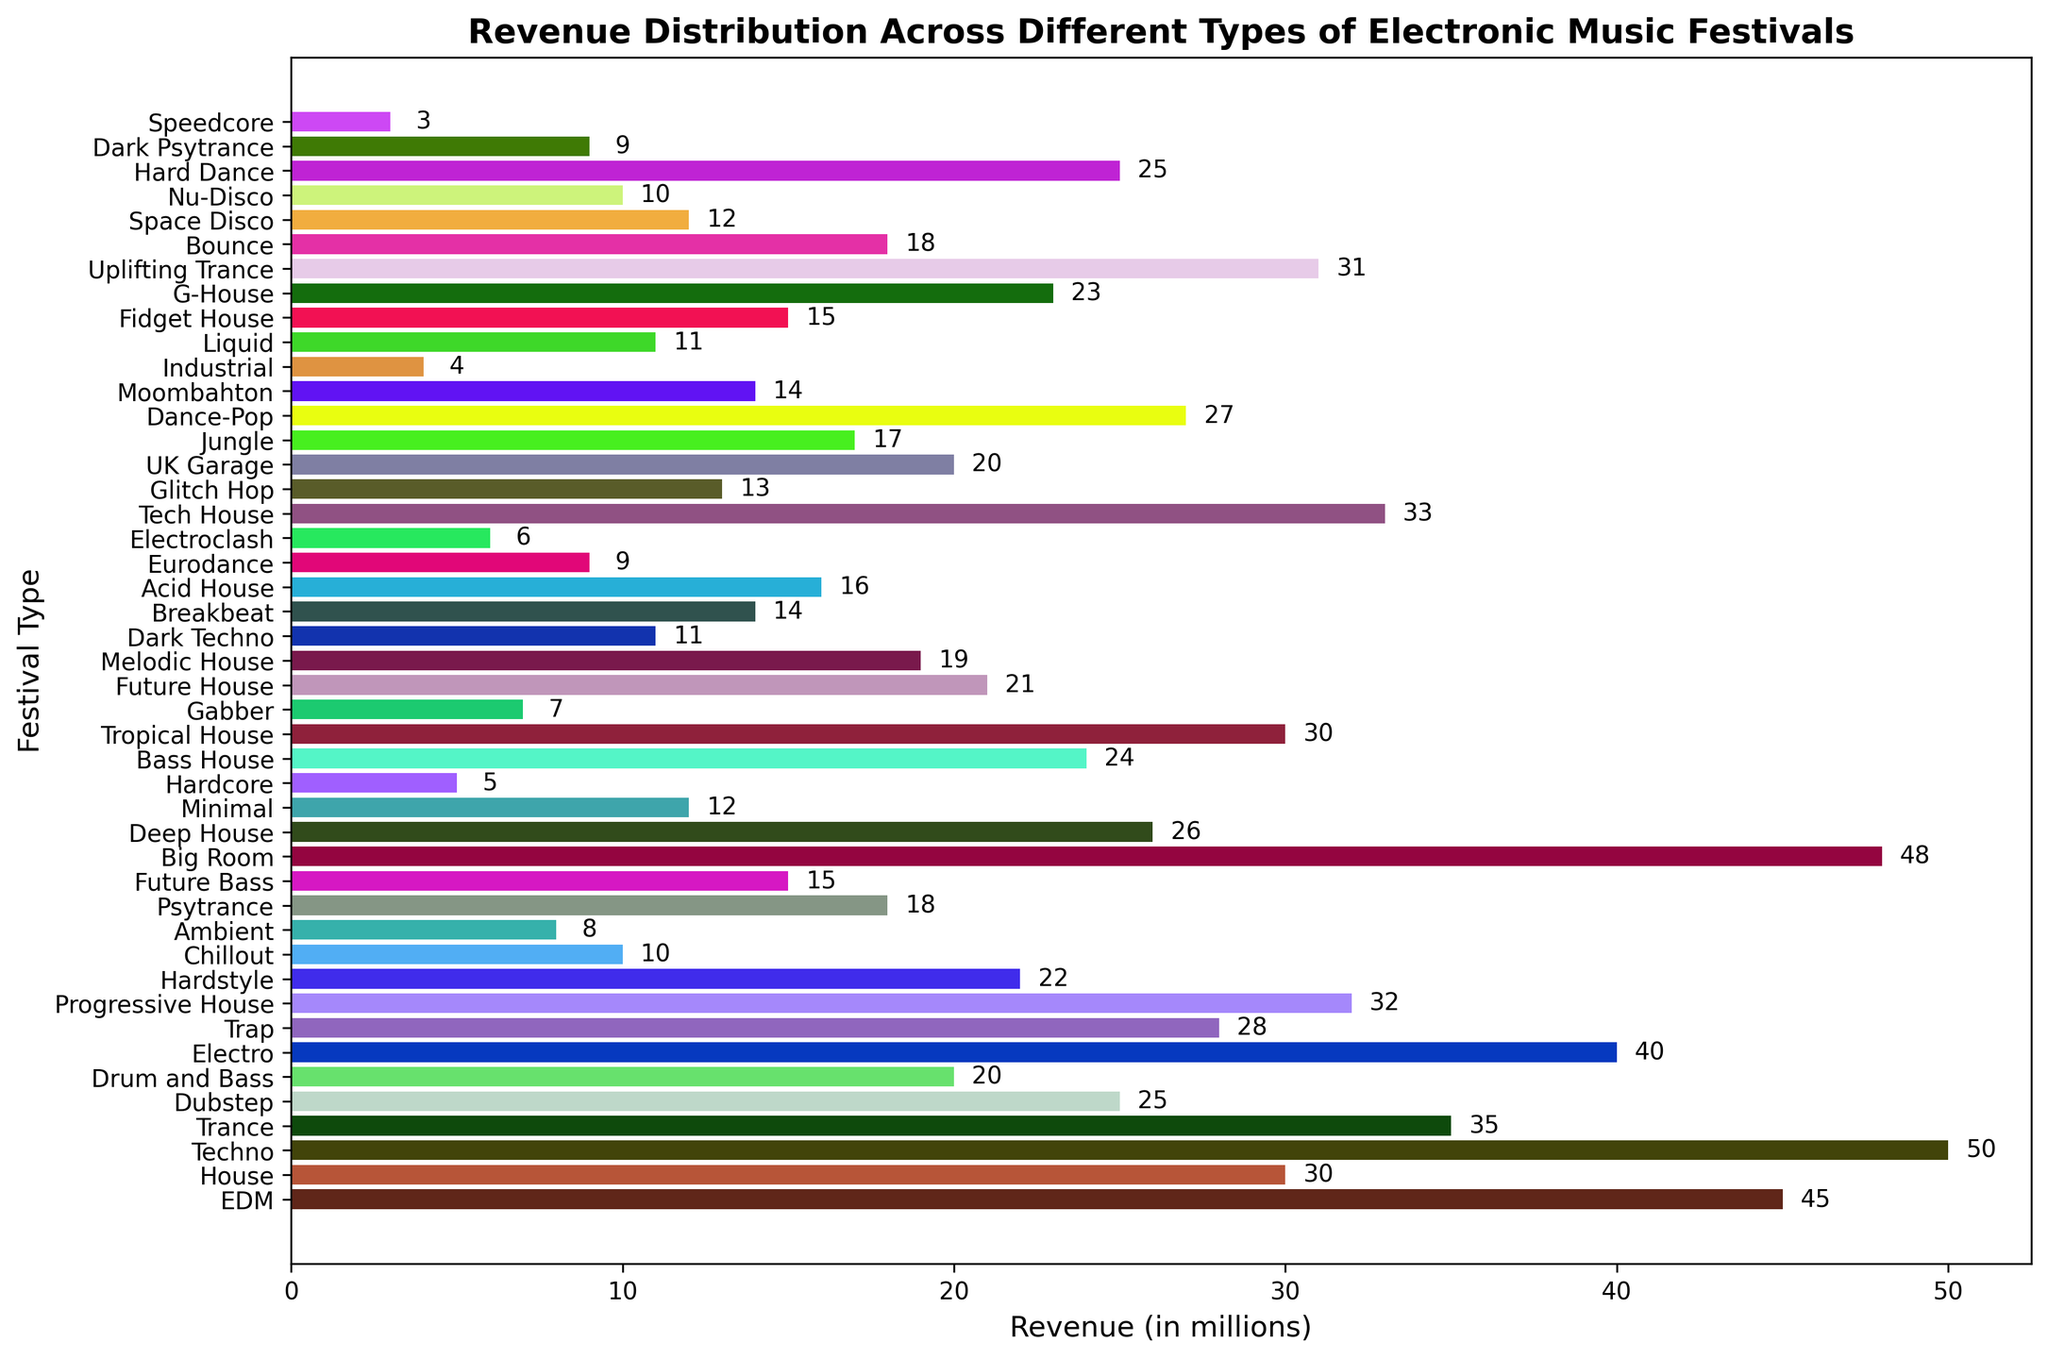Which type of festival generates the highest revenue? By inspecting the plot, the festival with the highest bar represents the highest revenue. The 'Big Room' festival reaches the highest point on the x-axis with a revenue of 48 million.
Answer: Big Room Which festival type has the smallest revenue and what is it? The smallest bar on the plot represents the lowest revenue. The 'Speedcore' festival type has the smallest bar with a revenue of 3 million.
Answer: Speedcore, 3 million How much more revenue does the Techno festival generate compared to the Dubstep festival? Techno generates 50 million and Dubstep generates 25 million. The difference is calculated by subtracting Dubstep's revenue from Techno's revenue: 50 - 25 = 25.
Answer: 25 million What is the total revenue generated by the top 3 highest-earning festival types? The top 3 highest-earning festival types are Big Room (48 million), Techno (50 million), and EDM (45 million). Summing these gives: 48 + 50 + 45 = 143 million.
Answer: 143 million Which festival type earns more revenue, Trance or Future Bass? By how much? The 'Trance' festival generates 35 million while 'Future Bass' generates 15 million. The difference can be found by subtracting the revenue of Future Bass from Trance's revenue: 35 - 15 = 20 million.
Answer: Trance, 20 million What is the total revenue generated by all festival types earning below 10 million individually? Festival types earning below 10 million are Speedcore (3), Industrial (4), Hardcore (5), Electroclash (6), Gabber (7), Ambient (8), Dark Psytrance (9), Eurodance (9), and Nu-Disco (10). Summing these gives: 3 + 4 + 5 + 6 + 7 + 8 + 9 + 9 + 10 = 61 million.
Answer: 61 million How many festival types generate exactly 30 million in revenue? By inspecting the bars labeled with '30' on the x-axis, there are two festival types: House and Tropical House that generate exactly 30 million in revenue.
Answer: 2 What is the range of revenues observed in the plot? The range is calculated by subtracting the smallest revenue from the largest revenue. The smallest revenue is 3 million (Speedcore), and the largest is 50 million (Techno). The range is 50 - 3 = 47 million.
Answer: 47 million 